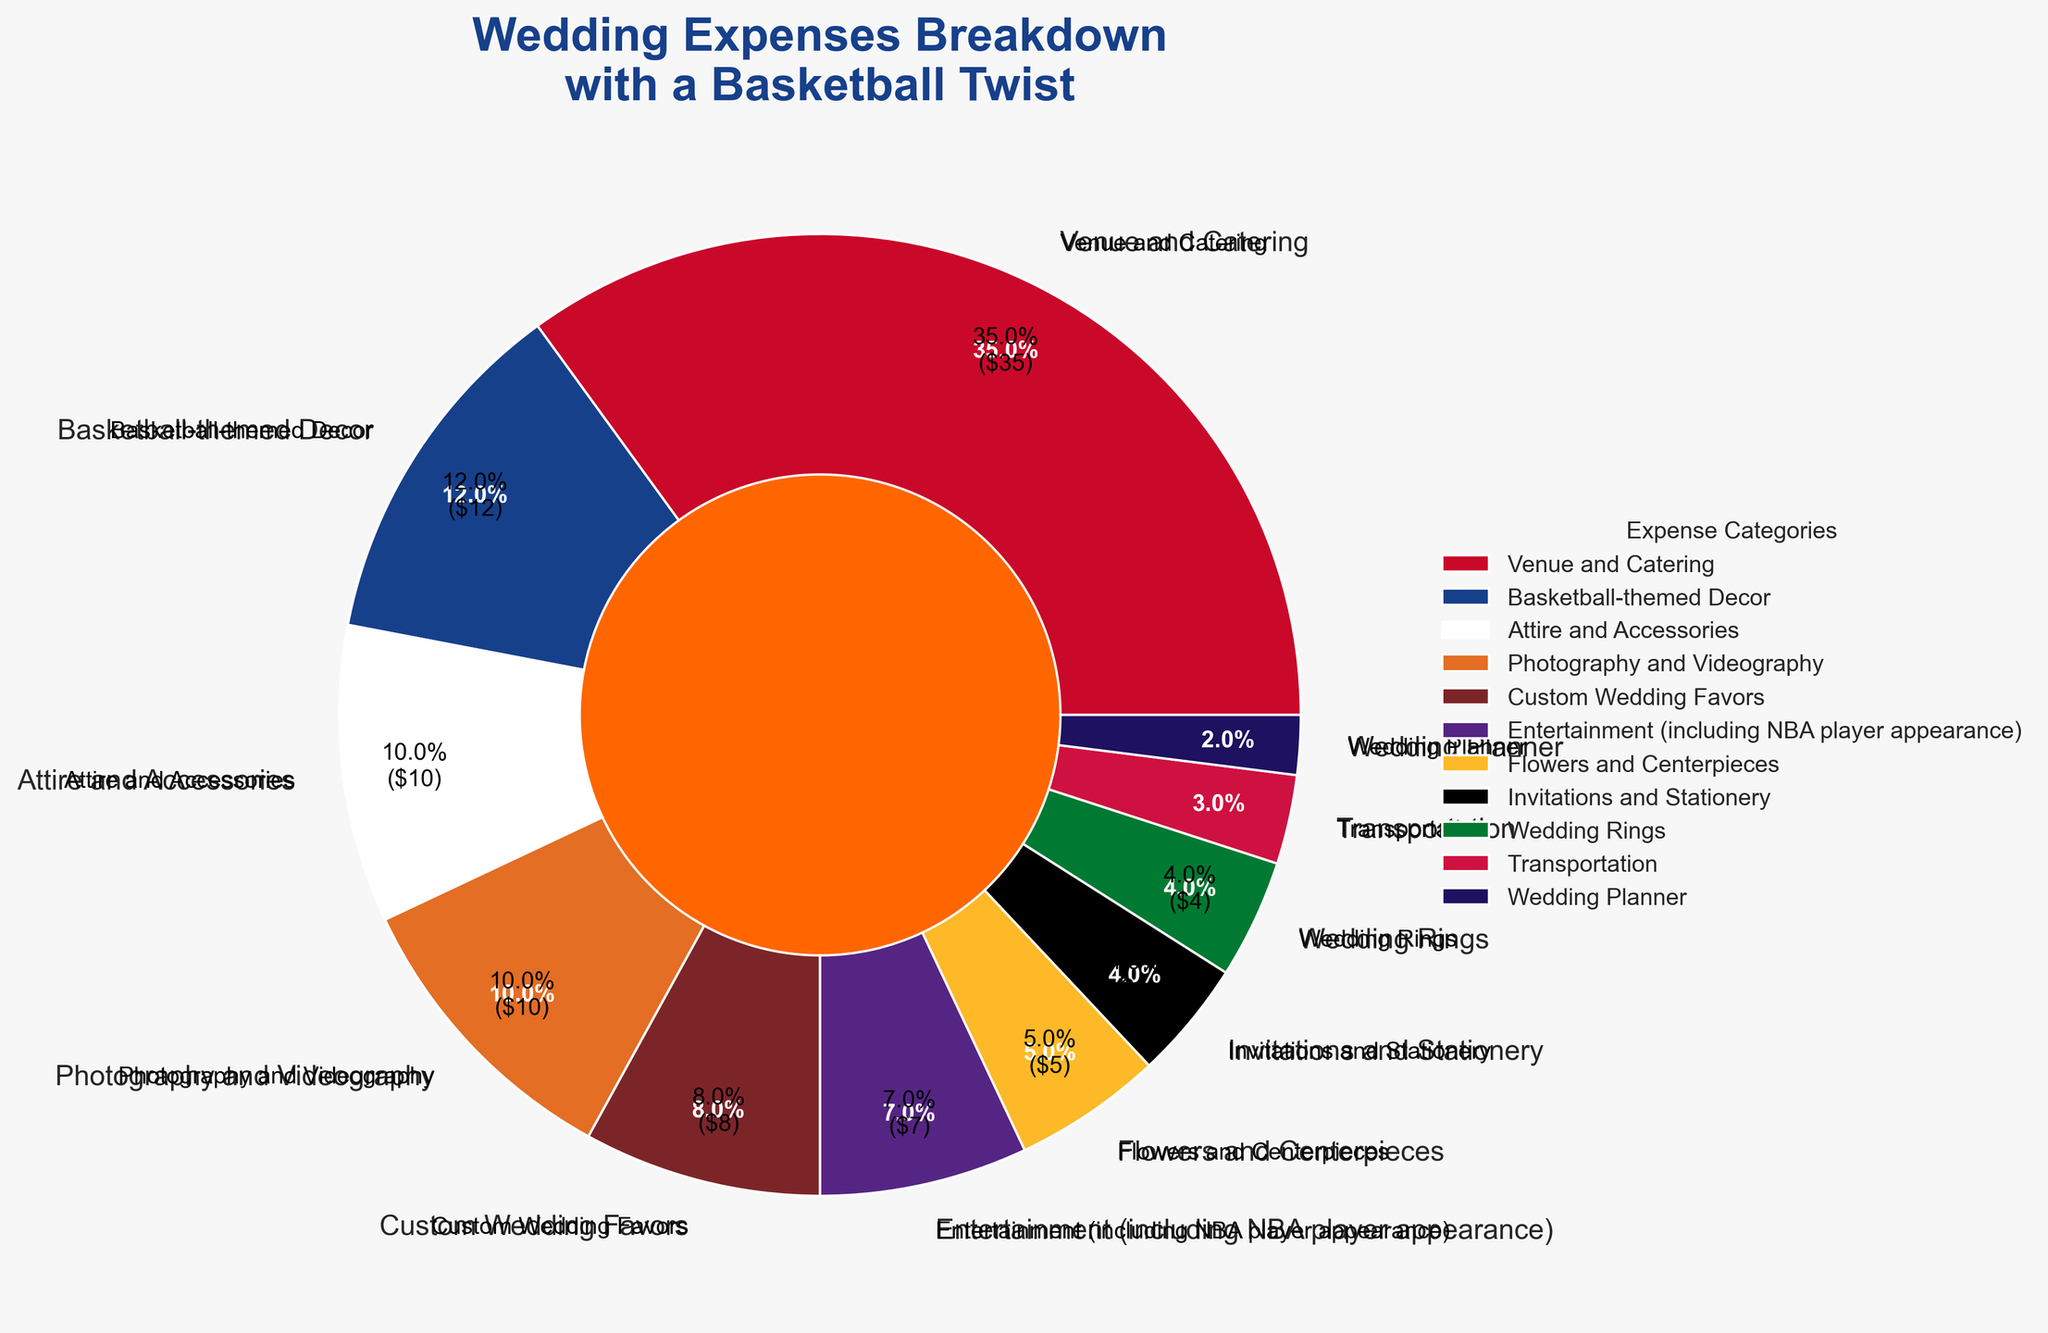What percentage of the total expenses is dedicated to the Venue and Catering category? The pie chart shows that the Venue and Catering category accounts for 35% of the total wedding expenses.
Answer: 35% What is the combined percentage of expenses for Attire and Accessories, Photography and Videography, and Custom Wedding Favors? The percentages for Attire and Accessories, Photography and Videography, and Custom Wedding Favors are 10%, 10%, and 8% respectively. Summing these up: 10% + 10% + 8% = 28%.
Answer: 28% Which category has a higher expense percentage, Flowers and Centerpieces or Invitations and Stationery? The pie chart indicates that Flowers and Centerpieces account for 5% of the expenses, while Invitations and Stationery account for 4%. Since 5% > 4%, Flowers and Centerpieces have a higher expense percentage.
Answer: Flowers and Centerpieces What is the total percentage of expenses categorized under Entertainment (including NBA player appearance) and Transportation? The pie chart shows that Entertainment accounts for 7% and Transportation accounts for 3%. Summing these gives: 7% + 3% = 10%.
Answer: 10% By how much does the expense percentage of the Wedding Rings category differ from the Wedding Planner category? According to the pie chart, Wedding Rings account for 4% and the Wedding Planner for 2%. The difference is 4% - 2% = 2%.
Answer: 2% Which category uses the color representing the basketball team's home jersey colors (red, white, and blue)? The pie chart associates certain colors with categories, the Basketball-themed Decor uses colors typically associated with a basketball team's home jersey (red, white, and blue).
Answer: Basketball-themed Decor How do the expenses for Venue and Catering compare to the total combined expenses of Basketball-themed Decor and Entertainment? The Venue and Catering expense is 35%. The combined expense of Basketball-themed Decor (12%) and Entertainment (7%) is 12% + 7% = 19%. Since 35% > 19%, Venue and Catering has a higher expense.
Answer: Venue and Catering is higher What category constitutes the smallest part of the total wedding expenses? The pie chart shows the Wedding Planner category with the smallest percentage which is 2%.
Answer: Wedding Planner If the total wedding expense is $20,000, what is the dollar amount allocated for Photography and Videography? Photography and Videography account for 10% of the total expenses. If the total wedding expense is $20,000, then 10% of $20,000 is: 0.10 * 20,000 = $2,000.
Answer: $2,000 